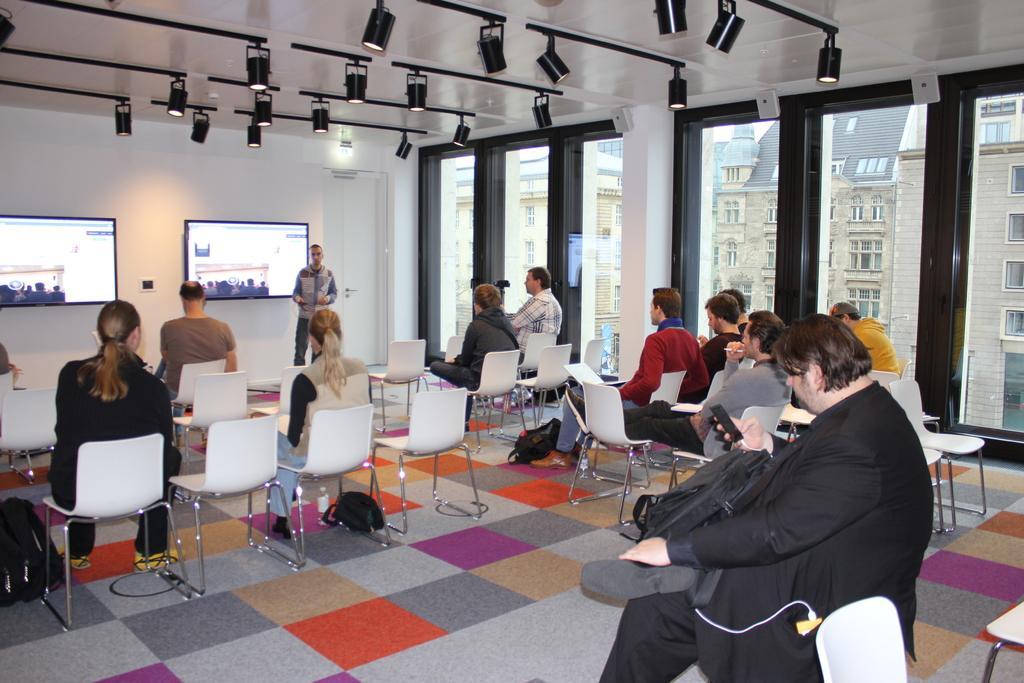Please provide a concise description of this image. In this image, I can see few people sitting on the chairs. These are the bags, which are placed on the floor. Here is a person standing. I can see two screens, which are attached to the wall. This is the door with a door handle. These are the lights attached to the roof. These are the glass windows. I can see few empty chairs. I can see the buildings with windows through the glass window. 